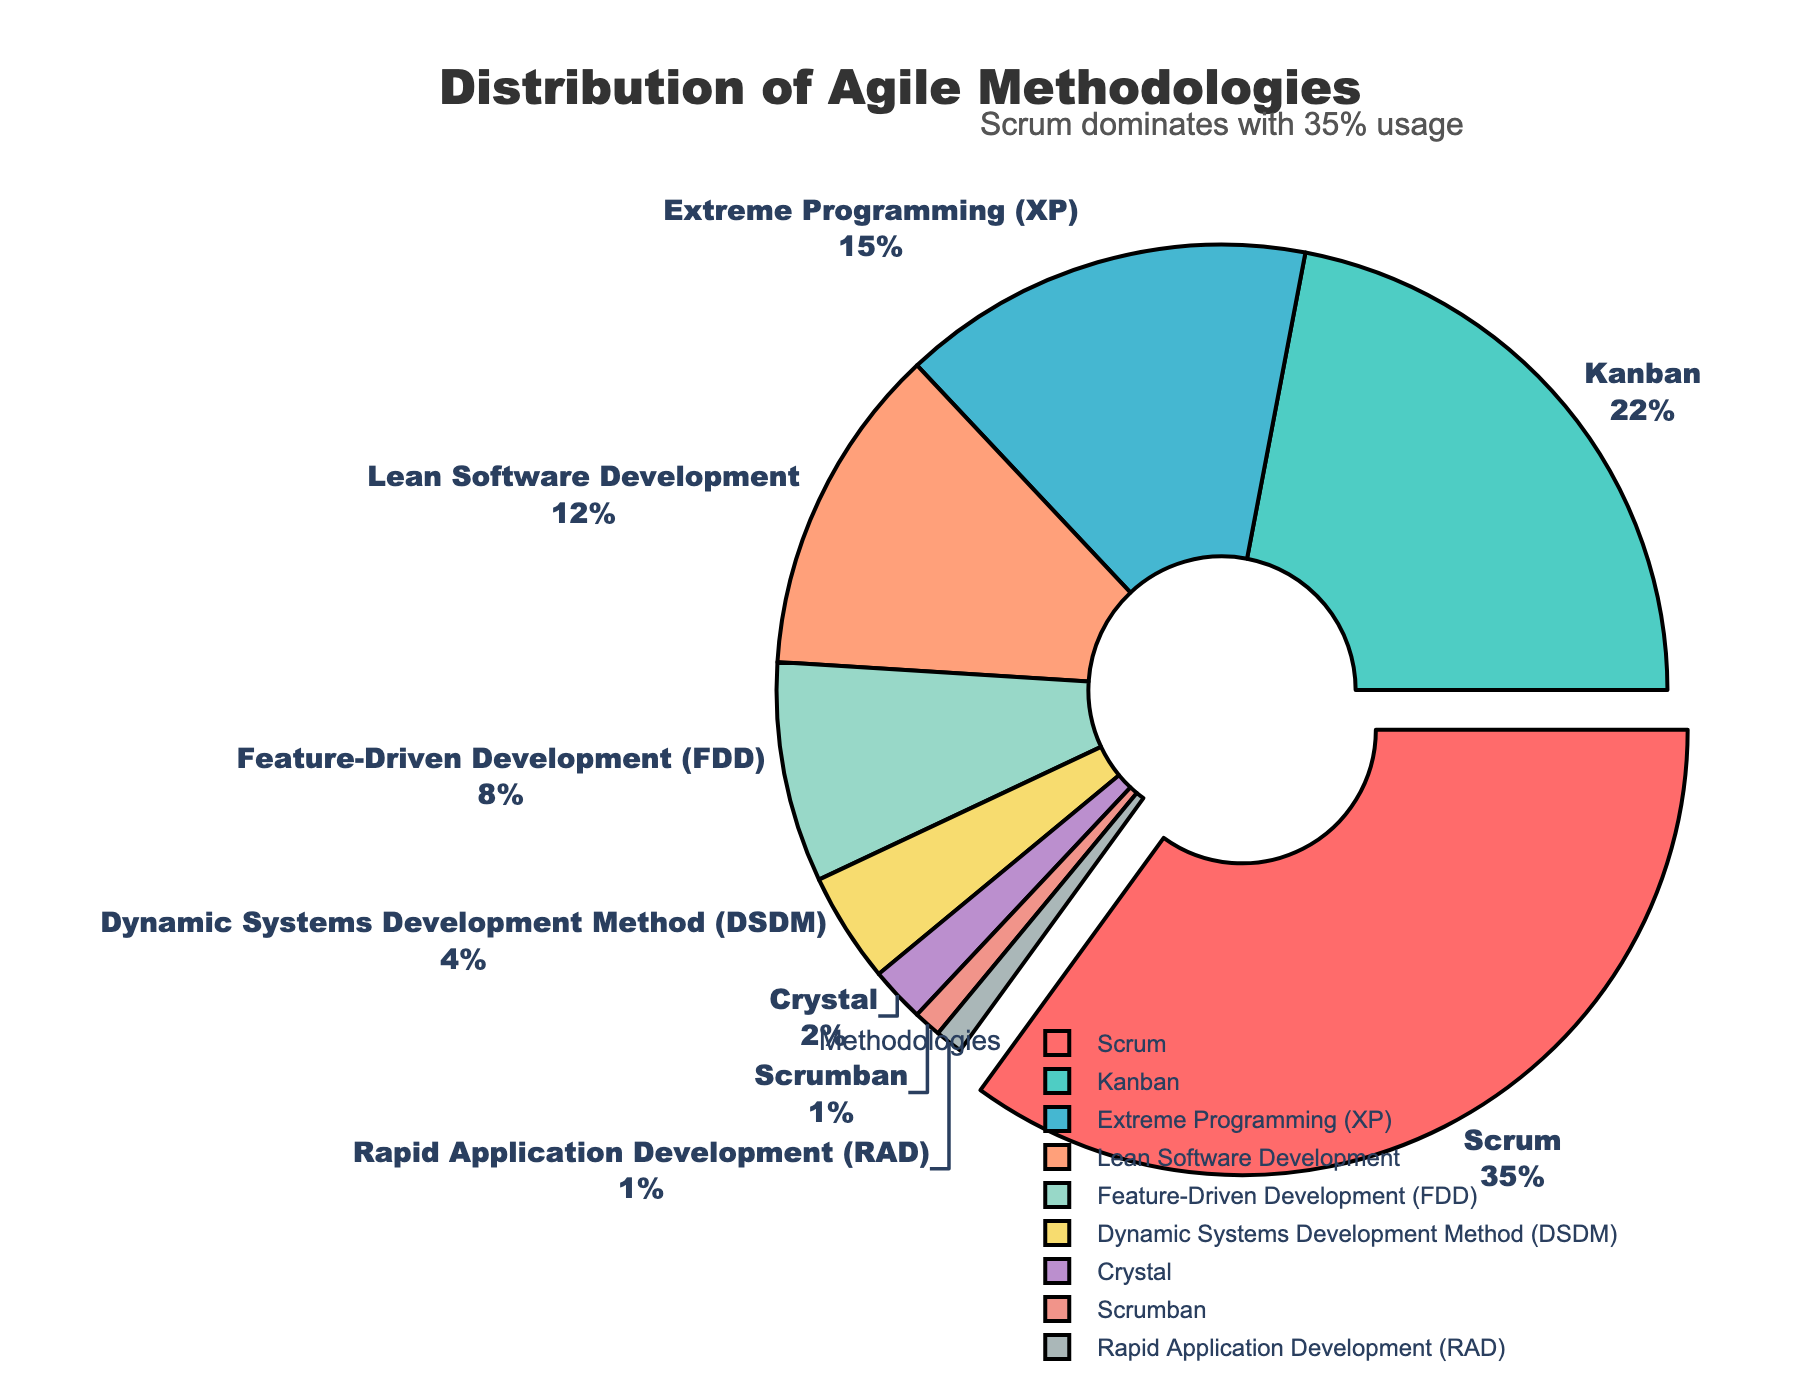What percentage of projects use Scrum? Identify the segment labeled "Scrum" which has a percentage value attached to it.
Answer: 35% Which methodology is used the least among the listed ones? Look for the smallest percentage value in the pie chart, which corresponds to the "Scrumban" and "Rapid Application Development (RAD)" segments.
Answer: Scrumban and Rapid Application Development (RAD) How much more is Scrum used compared to Feature-Driven Development (FDD)? Subtract the percentage of Feature-Driven Development (FDD) from the percentage of Scrum. \(35\% - 8\% = 27\%\)
Answer: 27% Which methodologies combined make up more than half of the projects? Add up the percentages from the largest values until exceeding 50%. \(35\% (Scrum) + 22\% (Kanban) = 57\%\)
Answer: Scrum and Kanban Are there more projects using Lean Software Development or Extreme Programming (XP)? Compare the percentage values of Lean Software Development and Extreme Programming (XP). 12% for Lean Software Development and 15% for Extreme Programming (XP).
Answer: Extreme Programming (XP) If we combine the usage percentages of methodologies used by less than 10% of the projects each, what is the total? Add the percentages of Extreme Programming (15%), Lean Software Development (12%), Feature-Driven Development (8%), Dynamic Systems Development Method (4%), Crystal (2%), Scrumban (1%), and Rapid Application Development (1%). \(15\% + 12\% + 8\% + 4\% + 2\% + 1\% + 1\% = 43\%\)
Answer: 43% Which methodologies have a usage difference of 10% or less? Compare the percentages to find those whose differences are within 10%. For example, Kanban (22%) and Extreme Programming (15%), Lean Software Development (12%) and Feature-Driven Development (8%).
Answer: Kanban and Extreme Programming, Lean Software Development and Feature-Driven Development What proportion of the chart is made up of methodologies other than Scrum and Kanban? Subtract the combined percentage of Scrum and Kanban from 100%. \(100\% - (35\% + 22\%) = 43\%\)
Answer: 43% Which methodology has the second highest usage? Identify the segment with the second largest percentage value after Scrum.
Answer: Kanban 